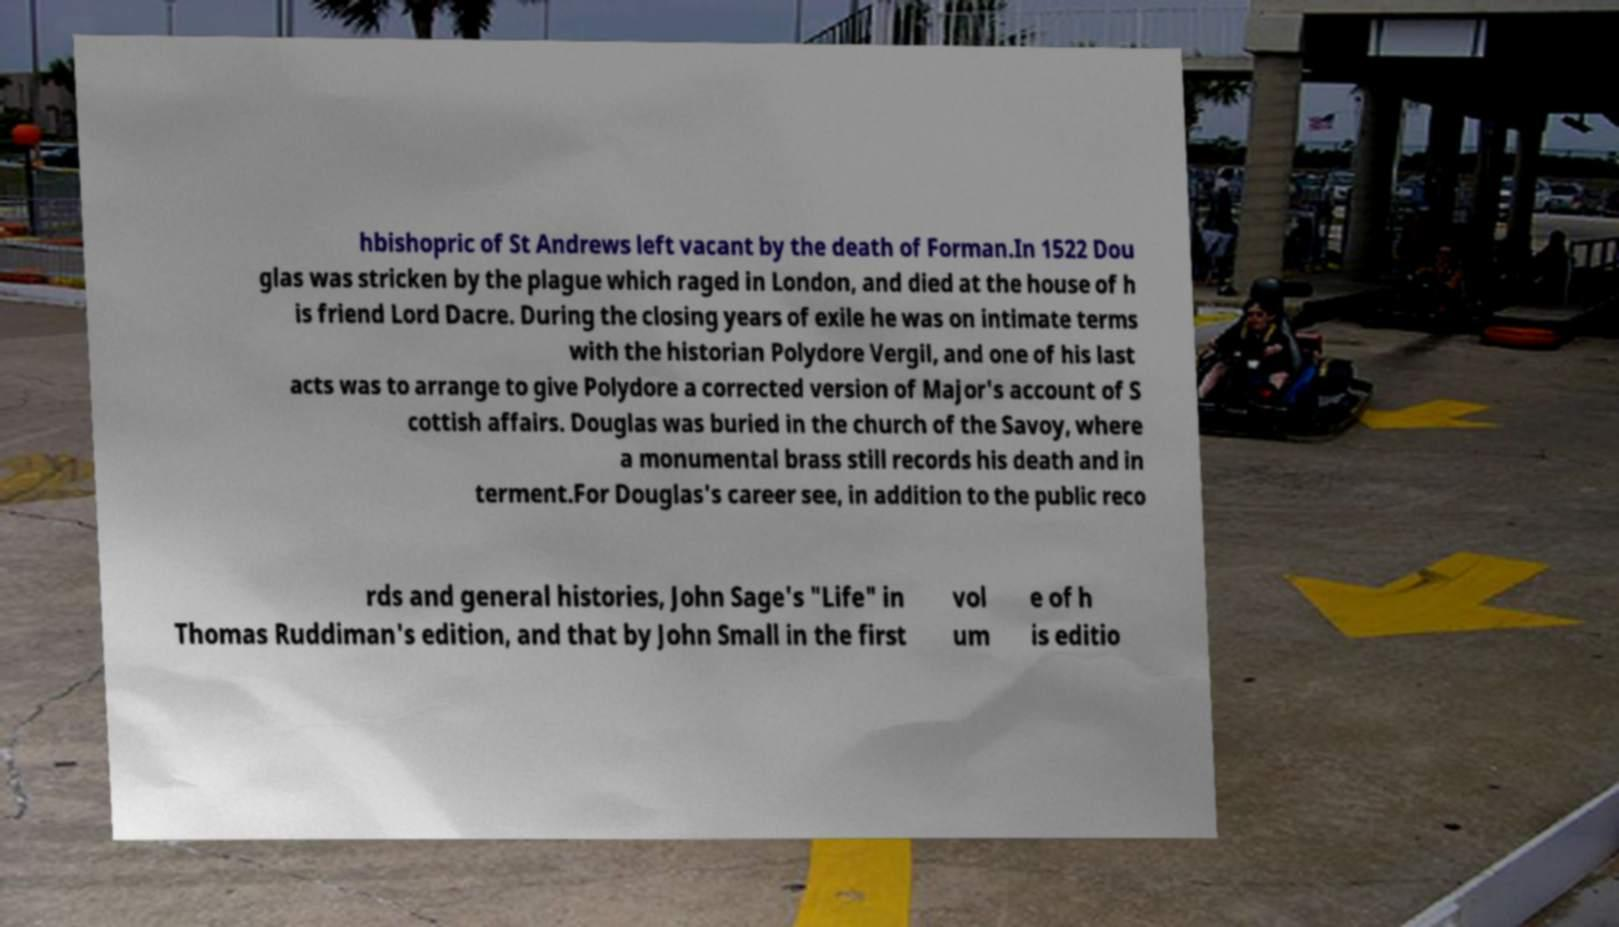Can you accurately transcribe the text from the provided image for me? hbishopric of St Andrews left vacant by the death of Forman.In 1522 Dou glas was stricken by the plague which raged in London, and died at the house of h is friend Lord Dacre. During the closing years of exile he was on intimate terms with the historian Polydore Vergil, and one of his last acts was to arrange to give Polydore a corrected version of Major's account of S cottish affairs. Douglas was buried in the church of the Savoy, where a monumental brass still records his death and in terment.For Douglas's career see, in addition to the public reco rds and general histories, John Sage's "Life" in Thomas Ruddiman's edition, and that by John Small in the first vol um e of h is editio 